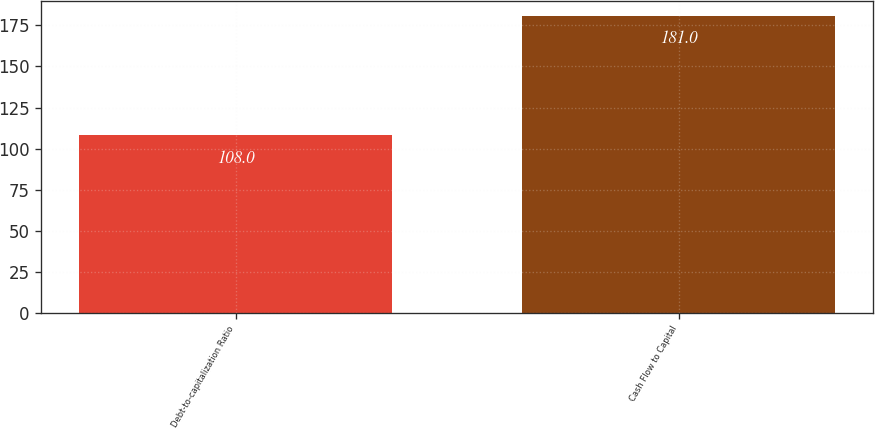Convert chart to OTSL. <chart><loc_0><loc_0><loc_500><loc_500><bar_chart><fcel>Debt-to-capitalization Ratio<fcel>Cash Flow to Capital<nl><fcel>108<fcel>181<nl></chart> 